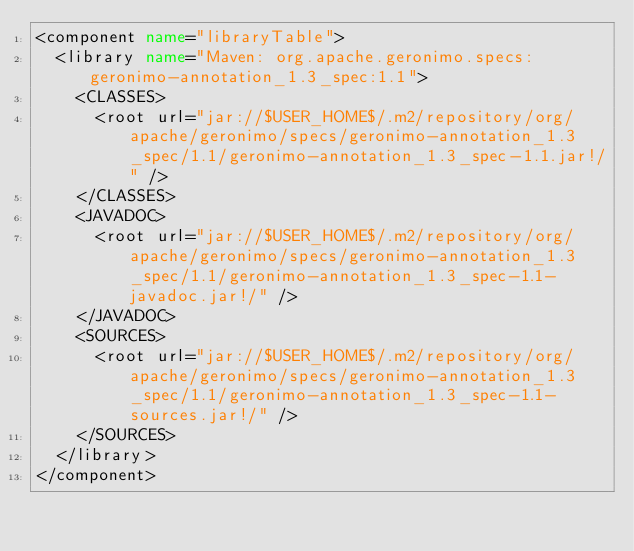Convert code to text. <code><loc_0><loc_0><loc_500><loc_500><_XML_><component name="libraryTable">
  <library name="Maven: org.apache.geronimo.specs:geronimo-annotation_1.3_spec:1.1">
    <CLASSES>
      <root url="jar://$USER_HOME$/.m2/repository/org/apache/geronimo/specs/geronimo-annotation_1.3_spec/1.1/geronimo-annotation_1.3_spec-1.1.jar!/" />
    </CLASSES>
    <JAVADOC>
      <root url="jar://$USER_HOME$/.m2/repository/org/apache/geronimo/specs/geronimo-annotation_1.3_spec/1.1/geronimo-annotation_1.3_spec-1.1-javadoc.jar!/" />
    </JAVADOC>
    <SOURCES>
      <root url="jar://$USER_HOME$/.m2/repository/org/apache/geronimo/specs/geronimo-annotation_1.3_spec/1.1/geronimo-annotation_1.3_spec-1.1-sources.jar!/" />
    </SOURCES>
  </library>
</component></code> 